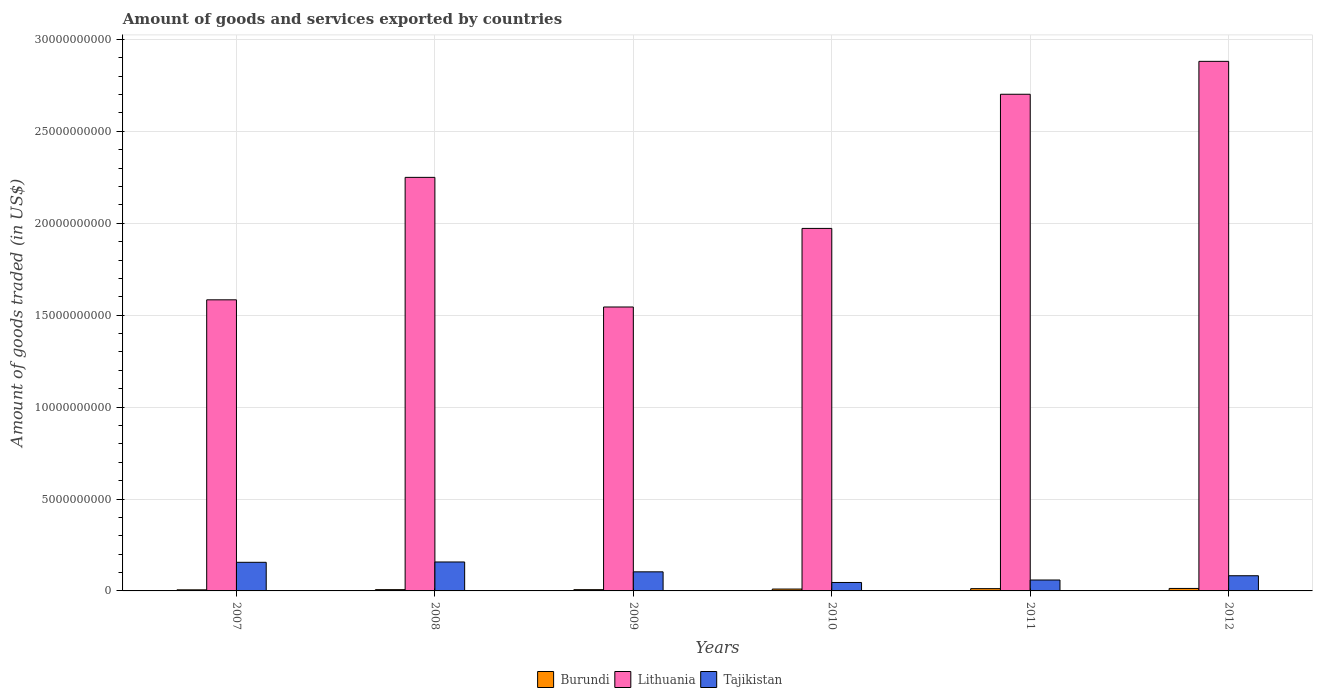How many different coloured bars are there?
Your answer should be very brief. 3. How many groups of bars are there?
Your response must be concise. 6. Are the number of bars per tick equal to the number of legend labels?
Offer a terse response. Yes. Are the number of bars on each tick of the X-axis equal?
Provide a short and direct response. Yes. How many bars are there on the 3rd tick from the left?
Your answer should be very brief. 3. How many bars are there on the 3rd tick from the right?
Provide a succinct answer. 3. In how many cases, is the number of bars for a given year not equal to the number of legend labels?
Your answer should be very brief. 0. What is the total amount of goods and services exported in Lithuania in 2007?
Ensure brevity in your answer.  1.58e+1. Across all years, what is the maximum total amount of goods and services exported in Burundi?
Keep it short and to the point. 1.35e+08. Across all years, what is the minimum total amount of goods and services exported in Tajikistan?
Give a very brief answer. 4.59e+08. In which year was the total amount of goods and services exported in Lithuania maximum?
Provide a succinct answer. 2012. What is the total total amount of goods and services exported in Lithuania in the graph?
Offer a terse response. 1.29e+11. What is the difference between the total amount of goods and services exported in Tajikistan in 2007 and that in 2008?
Keep it short and to the point. -1.80e+07. What is the difference between the total amount of goods and services exported in Burundi in 2009 and the total amount of goods and services exported in Lithuania in 2012?
Provide a short and direct response. -2.87e+1. What is the average total amount of goods and services exported in Burundi per year?
Provide a succinct answer. 9.28e+07. In the year 2010, what is the difference between the total amount of goods and services exported in Lithuania and total amount of goods and services exported in Burundi?
Offer a very short reply. 1.96e+1. What is the ratio of the total amount of goods and services exported in Tajikistan in 2007 to that in 2010?
Offer a terse response. 3.39. Is the total amount of goods and services exported in Tajikistan in 2007 less than that in 2011?
Provide a succinct answer. No. Is the difference between the total amount of goods and services exported in Lithuania in 2007 and 2012 greater than the difference between the total amount of goods and services exported in Burundi in 2007 and 2012?
Provide a short and direct response. No. What is the difference between the highest and the second highest total amount of goods and services exported in Tajikistan?
Provide a short and direct response. 1.80e+07. What is the difference between the highest and the lowest total amount of goods and services exported in Burundi?
Keep it short and to the point. 7.59e+07. In how many years, is the total amount of goods and services exported in Lithuania greater than the average total amount of goods and services exported in Lithuania taken over all years?
Your answer should be very brief. 3. What does the 3rd bar from the left in 2010 represents?
Your answer should be compact. Tajikistan. What does the 3rd bar from the right in 2009 represents?
Make the answer very short. Burundi. Are the values on the major ticks of Y-axis written in scientific E-notation?
Ensure brevity in your answer.  No. Does the graph contain any zero values?
Make the answer very short. No. How are the legend labels stacked?
Your answer should be compact. Horizontal. What is the title of the graph?
Your answer should be compact. Amount of goods and services exported by countries. Does "Suriname" appear as one of the legend labels in the graph?
Make the answer very short. No. What is the label or title of the Y-axis?
Offer a terse response. Amount of goods traded (in US$). What is the Amount of goods traded (in US$) in Burundi in 2007?
Keep it short and to the point. 5.88e+07. What is the Amount of goods traded (in US$) of Lithuania in 2007?
Offer a very short reply. 1.58e+1. What is the Amount of goods traded (in US$) in Tajikistan in 2007?
Give a very brief answer. 1.56e+09. What is the Amount of goods traded (in US$) in Burundi in 2008?
Offer a terse response. 6.96e+07. What is the Amount of goods traded (in US$) in Lithuania in 2008?
Ensure brevity in your answer.  2.25e+1. What is the Amount of goods traded (in US$) in Tajikistan in 2008?
Ensure brevity in your answer.  1.57e+09. What is the Amount of goods traded (in US$) in Burundi in 2009?
Offer a very short reply. 6.84e+07. What is the Amount of goods traded (in US$) in Lithuania in 2009?
Ensure brevity in your answer.  1.54e+1. What is the Amount of goods traded (in US$) of Tajikistan in 2009?
Keep it short and to the point. 1.04e+09. What is the Amount of goods traded (in US$) of Burundi in 2010?
Provide a succinct answer. 1.01e+08. What is the Amount of goods traded (in US$) in Lithuania in 2010?
Keep it short and to the point. 1.97e+1. What is the Amount of goods traded (in US$) of Tajikistan in 2010?
Offer a very short reply. 4.59e+08. What is the Amount of goods traded (in US$) of Burundi in 2011?
Your response must be concise. 1.24e+08. What is the Amount of goods traded (in US$) in Lithuania in 2011?
Your answer should be compact. 2.70e+1. What is the Amount of goods traded (in US$) of Tajikistan in 2011?
Make the answer very short. 5.93e+08. What is the Amount of goods traded (in US$) in Burundi in 2012?
Ensure brevity in your answer.  1.35e+08. What is the Amount of goods traded (in US$) of Lithuania in 2012?
Make the answer very short. 2.88e+1. What is the Amount of goods traded (in US$) of Tajikistan in 2012?
Keep it short and to the point. 8.26e+08. Across all years, what is the maximum Amount of goods traded (in US$) in Burundi?
Make the answer very short. 1.35e+08. Across all years, what is the maximum Amount of goods traded (in US$) in Lithuania?
Make the answer very short. 2.88e+1. Across all years, what is the maximum Amount of goods traded (in US$) of Tajikistan?
Your answer should be very brief. 1.57e+09. Across all years, what is the minimum Amount of goods traded (in US$) in Burundi?
Give a very brief answer. 5.88e+07. Across all years, what is the minimum Amount of goods traded (in US$) of Lithuania?
Provide a short and direct response. 1.54e+1. Across all years, what is the minimum Amount of goods traded (in US$) of Tajikistan?
Keep it short and to the point. 4.59e+08. What is the total Amount of goods traded (in US$) of Burundi in the graph?
Give a very brief answer. 5.57e+08. What is the total Amount of goods traded (in US$) in Lithuania in the graph?
Your response must be concise. 1.29e+11. What is the total Amount of goods traded (in US$) of Tajikistan in the graph?
Your answer should be very brief. 6.05e+09. What is the difference between the Amount of goods traded (in US$) in Burundi in 2007 and that in 2008?
Your answer should be compact. -1.08e+07. What is the difference between the Amount of goods traded (in US$) in Lithuania in 2007 and that in 2008?
Offer a terse response. -6.66e+09. What is the difference between the Amount of goods traded (in US$) of Tajikistan in 2007 and that in 2008?
Provide a succinct answer. -1.80e+07. What is the difference between the Amount of goods traded (in US$) in Burundi in 2007 and that in 2009?
Your answer should be very brief. -9.58e+06. What is the difference between the Amount of goods traded (in US$) in Lithuania in 2007 and that in 2009?
Offer a terse response. 3.91e+08. What is the difference between the Amount of goods traded (in US$) in Tajikistan in 2007 and that in 2009?
Give a very brief answer. 5.18e+08. What is the difference between the Amount of goods traded (in US$) of Burundi in 2007 and that in 2010?
Make the answer very short. -4.24e+07. What is the difference between the Amount of goods traded (in US$) of Lithuania in 2007 and that in 2010?
Keep it short and to the point. -3.88e+09. What is the difference between the Amount of goods traded (in US$) in Tajikistan in 2007 and that in 2010?
Ensure brevity in your answer.  1.10e+09. What is the difference between the Amount of goods traded (in US$) of Burundi in 2007 and that in 2011?
Your response must be concise. -6.51e+07. What is the difference between the Amount of goods traded (in US$) in Lithuania in 2007 and that in 2011?
Keep it short and to the point. -1.12e+1. What is the difference between the Amount of goods traded (in US$) in Tajikistan in 2007 and that in 2011?
Offer a terse response. 9.64e+08. What is the difference between the Amount of goods traded (in US$) in Burundi in 2007 and that in 2012?
Offer a terse response. -7.59e+07. What is the difference between the Amount of goods traded (in US$) of Lithuania in 2007 and that in 2012?
Make the answer very short. -1.30e+1. What is the difference between the Amount of goods traded (in US$) in Tajikistan in 2007 and that in 2012?
Offer a terse response. 7.31e+08. What is the difference between the Amount of goods traded (in US$) in Burundi in 2008 and that in 2009?
Keep it short and to the point. 1.23e+06. What is the difference between the Amount of goods traded (in US$) in Lithuania in 2008 and that in 2009?
Make the answer very short. 7.05e+09. What is the difference between the Amount of goods traded (in US$) in Tajikistan in 2008 and that in 2009?
Give a very brief answer. 5.36e+08. What is the difference between the Amount of goods traded (in US$) in Burundi in 2008 and that in 2010?
Provide a succinct answer. -3.16e+07. What is the difference between the Amount of goods traded (in US$) of Lithuania in 2008 and that in 2010?
Keep it short and to the point. 2.78e+09. What is the difference between the Amount of goods traded (in US$) of Tajikistan in 2008 and that in 2010?
Ensure brevity in your answer.  1.12e+09. What is the difference between the Amount of goods traded (in US$) of Burundi in 2008 and that in 2011?
Provide a succinct answer. -5.43e+07. What is the difference between the Amount of goods traded (in US$) of Lithuania in 2008 and that in 2011?
Keep it short and to the point. -4.52e+09. What is the difference between the Amount of goods traded (in US$) of Tajikistan in 2008 and that in 2011?
Offer a terse response. 9.82e+08. What is the difference between the Amount of goods traded (in US$) in Burundi in 2008 and that in 2012?
Give a very brief answer. -6.51e+07. What is the difference between the Amount of goods traded (in US$) of Lithuania in 2008 and that in 2012?
Your answer should be very brief. -6.31e+09. What is the difference between the Amount of goods traded (in US$) of Tajikistan in 2008 and that in 2012?
Your answer should be compact. 7.49e+08. What is the difference between the Amount of goods traded (in US$) in Burundi in 2009 and that in 2010?
Provide a short and direct response. -3.28e+07. What is the difference between the Amount of goods traded (in US$) in Lithuania in 2009 and that in 2010?
Give a very brief answer. -4.27e+09. What is the difference between the Amount of goods traded (in US$) in Tajikistan in 2009 and that in 2010?
Your answer should be very brief. 5.79e+08. What is the difference between the Amount of goods traded (in US$) in Burundi in 2009 and that in 2011?
Make the answer very short. -5.56e+07. What is the difference between the Amount of goods traded (in US$) of Lithuania in 2009 and that in 2011?
Offer a very short reply. -1.16e+1. What is the difference between the Amount of goods traded (in US$) in Tajikistan in 2009 and that in 2011?
Your response must be concise. 4.45e+08. What is the difference between the Amount of goods traded (in US$) of Burundi in 2009 and that in 2012?
Provide a short and direct response. -6.63e+07. What is the difference between the Amount of goods traded (in US$) of Lithuania in 2009 and that in 2012?
Provide a succinct answer. -1.34e+1. What is the difference between the Amount of goods traded (in US$) in Tajikistan in 2009 and that in 2012?
Your response must be concise. 2.13e+08. What is the difference between the Amount of goods traded (in US$) in Burundi in 2010 and that in 2011?
Offer a terse response. -2.27e+07. What is the difference between the Amount of goods traded (in US$) of Lithuania in 2010 and that in 2011?
Ensure brevity in your answer.  -7.30e+09. What is the difference between the Amount of goods traded (in US$) in Tajikistan in 2010 and that in 2011?
Ensure brevity in your answer.  -1.34e+08. What is the difference between the Amount of goods traded (in US$) in Burundi in 2010 and that in 2012?
Make the answer very short. -3.35e+07. What is the difference between the Amount of goods traded (in US$) in Lithuania in 2010 and that in 2012?
Keep it short and to the point. -9.09e+09. What is the difference between the Amount of goods traded (in US$) in Tajikistan in 2010 and that in 2012?
Your response must be concise. -3.67e+08. What is the difference between the Amount of goods traded (in US$) in Burundi in 2011 and that in 2012?
Your answer should be compact. -1.07e+07. What is the difference between the Amount of goods traded (in US$) in Lithuania in 2011 and that in 2012?
Make the answer very short. -1.79e+09. What is the difference between the Amount of goods traded (in US$) of Tajikistan in 2011 and that in 2012?
Make the answer very short. -2.33e+08. What is the difference between the Amount of goods traded (in US$) in Burundi in 2007 and the Amount of goods traded (in US$) in Lithuania in 2008?
Make the answer very short. -2.24e+1. What is the difference between the Amount of goods traded (in US$) of Burundi in 2007 and the Amount of goods traded (in US$) of Tajikistan in 2008?
Provide a short and direct response. -1.52e+09. What is the difference between the Amount of goods traded (in US$) in Lithuania in 2007 and the Amount of goods traded (in US$) in Tajikistan in 2008?
Offer a very short reply. 1.43e+1. What is the difference between the Amount of goods traded (in US$) in Burundi in 2007 and the Amount of goods traded (in US$) in Lithuania in 2009?
Your response must be concise. -1.54e+1. What is the difference between the Amount of goods traded (in US$) of Burundi in 2007 and the Amount of goods traded (in US$) of Tajikistan in 2009?
Give a very brief answer. -9.80e+08. What is the difference between the Amount of goods traded (in US$) of Lithuania in 2007 and the Amount of goods traded (in US$) of Tajikistan in 2009?
Keep it short and to the point. 1.48e+1. What is the difference between the Amount of goods traded (in US$) of Burundi in 2007 and the Amount of goods traded (in US$) of Lithuania in 2010?
Provide a short and direct response. -1.97e+1. What is the difference between the Amount of goods traded (in US$) of Burundi in 2007 and the Amount of goods traded (in US$) of Tajikistan in 2010?
Make the answer very short. -4.00e+08. What is the difference between the Amount of goods traded (in US$) of Lithuania in 2007 and the Amount of goods traded (in US$) of Tajikistan in 2010?
Offer a terse response. 1.54e+1. What is the difference between the Amount of goods traded (in US$) in Burundi in 2007 and the Amount of goods traded (in US$) in Lithuania in 2011?
Your answer should be very brief. -2.70e+1. What is the difference between the Amount of goods traded (in US$) of Burundi in 2007 and the Amount of goods traded (in US$) of Tajikistan in 2011?
Offer a terse response. -5.35e+08. What is the difference between the Amount of goods traded (in US$) in Lithuania in 2007 and the Amount of goods traded (in US$) in Tajikistan in 2011?
Make the answer very short. 1.52e+1. What is the difference between the Amount of goods traded (in US$) of Burundi in 2007 and the Amount of goods traded (in US$) of Lithuania in 2012?
Give a very brief answer. -2.87e+1. What is the difference between the Amount of goods traded (in US$) in Burundi in 2007 and the Amount of goods traded (in US$) in Tajikistan in 2012?
Provide a succinct answer. -7.67e+08. What is the difference between the Amount of goods traded (in US$) in Lithuania in 2007 and the Amount of goods traded (in US$) in Tajikistan in 2012?
Your answer should be compact. 1.50e+1. What is the difference between the Amount of goods traded (in US$) of Burundi in 2008 and the Amount of goods traded (in US$) of Lithuania in 2009?
Your answer should be very brief. -1.54e+1. What is the difference between the Amount of goods traded (in US$) of Burundi in 2008 and the Amount of goods traded (in US$) of Tajikistan in 2009?
Offer a very short reply. -9.69e+08. What is the difference between the Amount of goods traded (in US$) in Lithuania in 2008 and the Amount of goods traded (in US$) in Tajikistan in 2009?
Keep it short and to the point. 2.15e+1. What is the difference between the Amount of goods traded (in US$) of Burundi in 2008 and the Amount of goods traded (in US$) of Lithuania in 2010?
Offer a very short reply. -1.97e+1. What is the difference between the Amount of goods traded (in US$) of Burundi in 2008 and the Amount of goods traded (in US$) of Tajikistan in 2010?
Provide a succinct answer. -3.89e+08. What is the difference between the Amount of goods traded (in US$) of Lithuania in 2008 and the Amount of goods traded (in US$) of Tajikistan in 2010?
Offer a terse response. 2.20e+1. What is the difference between the Amount of goods traded (in US$) in Burundi in 2008 and the Amount of goods traded (in US$) in Lithuania in 2011?
Give a very brief answer. -2.69e+1. What is the difference between the Amount of goods traded (in US$) in Burundi in 2008 and the Amount of goods traded (in US$) in Tajikistan in 2011?
Ensure brevity in your answer.  -5.24e+08. What is the difference between the Amount of goods traded (in US$) in Lithuania in 2008 and the Amount of goods traded (in US$) in Tajikistan in 2011?
Your response must be concise. 2.19e+1. What is the difference between the Amount of goods traded (in US$) in Burundi in 2008 and the Amount of goods traded (in US$) in Lithuania in 2012?
Keep it short and to the point. -2.87e+1. What is the difference between the Amount of goods traded (in US$) of Burundi in 2008 and the Amount of goods traded (in US$) of Tajikistan in 2012?
Offer a terse response. -7.56e+08. What is the difference between the Amount of goods traded (in US$) of Lithuania in 2008 and the Amount of goods traded (in US$) of Tajikistan in 2012?
Give a very brief answer. 2.17e+1. What is the difference between the Amount of goods traded (in US$) in Burundi in 2009 and the Amount of goods traded (in US$) in Lithuania in 2010?
Give a very brief answer. -1.97e+1. What is the difference between the Amount of goods traded (in US$) of Burundi in 2009 and the Amount of goods traded (in US$) of Tajikistan in 2010?
Offer a terse response. -3.91e+08. What is the difference between the Amount of goods traded (in US$) in Lithuania in 2009 and the Amount of goods traded (in US$) in Tajikistan in 2010?
Ensure brevity in your answer.  1.50e+1. What is the difference between the Amount of goods traded (in US$) of Burundi in 2009 and the Amount of goods traded (in US$) of Lithuania in 2011?
Keep it short and to the point. -2.69e+1. What is the difference between the Amount of goods traded (in US$) in Burundi in 2009 and the Amount of goods traded (in US$) in Tajikistan in 2011?
Make the answer very short. -5.25e+08. What is the difference between the Amount of goods traded (in US$) of Lithuania in 2009 and the Amount of goods traded (in US$) of Tajikistan in 2011?
Your response must be concise. 1.49e+1. What is the difference between the Amount of goods traded (in US$) in Burundi in 2009 and the Amount of goods traded (in US$) in Lithuania in 2012?
Provide a succinct answer. -2.87e+1. What is the difference between the Amount of goods traded (in US$) of Burundi in 2009 and the Amount of goods traded (in US$) of Tajikistan in 2012?
Your answer should be compact. -7.58e+08. What is the difference between the Amount of goods traded (in US$) in Lithuania in 2009 and the Amount of goods traded (in US$) in Tajikistan in 2012?
Offer a terse response. 1.46e+1. What is the difference between the Amount of goods traded (in US$) of Burundi in 2010 and the Amount of goods traded (in US$) of Lithuania in 2011?
Provide a succinct answer. -2.69e+1. What is the difference between the Amount of goods traded (in US$) in Burundi in 2010 and the Amount of goods traded (in US$) in Tajikistan in 2011?
Offer a terse response. -4.92e+08. What is the difference between the Amount of goods traded (in US$) in Lithuania in 2010 and the Amount of goods traded (in US$) in Tajikistan in 2011?
Provide a short and direct response. 1.91e+1. What is the difference between the Amount of goods traded (in US$) of Burundi in 2010 and the Amount of goods traded (in US$) of Lithuania in 2012?
Provide a succinct answer. -2.87e+1. What is the difference between the Amount of goods traded (in US$) in Burundi in 2010 and the Amount of goods traded (in US$) in Tajikistan in 2012?
Give a very brief answer. -7.25e+08. What is the difference between the Amount of goods traded (in US$) of Lithuania in 2010 and the Amount of goods traded (in US$) of Tajikistan in 2012?
Provide a short and direct response. 1.89e+1. What is the difference between the Amount of goods traded (in US$) of Burundi in 2011 and the Amount of goods traded (in US$) of Lithuania in 2012?
Provide a short and direct response. -2.87e+1. What is the difference between the Amount of goods traded (in US$) in Burundi in 2011 and the Amount of goods traded (in US$) in Tajikistan in 2012?
Offer a terse response. -7.02e+08. What is the difference between the Amount of goods traded (in US$) in Lithuania in 2011 and the Amount of goods traded (in US$) in Tajikistan in 2012?
Provide a succinct answer. 2.62e+1. What is the average Amount of goods traded (in US$) of Burundi per year?
Your response must be concise. 9.28e+07. What is the average Amount of goods traded (in US$) in Lithuania per year?
Offer a very short reply. 2.16e+1. What is the average Amount of goods traded (in US$) of Tajikistan per year?
Ensure brevity in your answer.  1.01e+09. In the year 2007, what is the difference between the Amount of goods traded (in US$) in Burundi and Amount of goods traded (in US$) in Lithuania?
Your response must be concise. -1.58e+1. In the year 2007, what is the difference between the Amount of goods traded (in US$) of Burundi and Amount of goods traded (in US$) of Tajikistan?
Provide a succinct answer. -1.50e+09. In the year 2007, what is the difference between the Amount of goods traded (in US$) of Lithuania and Amount of goods traded (in US$) of Tajikistan?
Provide a succinct answer. 1.43e+1. In the year 2008, what is the difference between the Amount of goods traded (in US$) in Burundi and Amount of goods traded (in US$) in Lithuania?
Your answer should be compact. -2.24e+1. In the year 2008, what is the difference between the Amount of goods traded (in US$) of Burundi and Amount of goods traded (in US$) of Tajikistan?
Your response must be concise. -1.51e+09. In the year 2008, what is the difference between the Amount of goods traded (in US$) of Lithuania and Amount of goods traded (in US$) of Tajikistan?
Ensure brevity in your answer.  2.09e+1. In the year 2009, what is the difference between the Amount of goods traded (in US$) of Burundi and Amount of goods traded (in US$) of Lithuania?
Offer a very short reply. -1.54e+1. In the year 2009, what is the difference between the Amount of goods traded (in US$) of Burundi and Amount of goods traded (in US$) of Tajikistan?
Provide a succinct answer. -9.70e+08. In the year 2009, what is the difference between the Amount of goods traded (in US$) of Lithuania and Amount of goods traded (in US$) of Tajikistan?
Make the answer very short. 1.44e+1. In the year 2010, what is the difference between the Amount of goods traded (in US$) of Burundi and Amount of goods traded (in US$) of Lithuania?
Offer a terse response. -1.96e+1. In the year 2010, what is the difference between the Amount of goods traded (in US$) of Burundi and Amount of goods traded (in US$) of Tajikistan?
Offer a terse response. -3.58e+08. In the year 2010, what is the difference between the Amount of goods traded (in US$) of Lithuania and Amount of goods traded (in US$) of Tajikistan?
Offer a terse response. 1.93e+1. In the year 2011, what is the difference between the Amount of goods traded (in US$) in Burundi and Amount of goods traded (in US$) in Lithuania?
Provide a succinct answer. -2.69e+1. In the year 2011, what is the difference between the Amount of goods traded (in US$) in Burundi and Amount of goods traded (in US$) in Tajikistan?
Keep it short and to the point. -4.69e+08. In the year 2011, what is the difference between the Amount of goods traded (in US$) in Lithuania and Amount of goods traded (in US$) in Tajikistan?
Offer a terse response. 2.64e+1. In the year 2012, what is the difference between the Amount of goods traded (in US$) in Burundi and Amount of goods traded (in US$) in Lithuania?
Offer a very short reply. -2.87e+1. In the year 2012, what is the difference between the Amount of goods traded (in US$) of Burundi and Amount of goods traded (in US$) of Tajikistan?
Your answer should be compact. -6.91e+08. In the year 2012, what is the difference between the Amount of goods traded (in US$) of Lithuania and Amount of goods traded (in US$) of Tajikistan?
Offer a very short reply. 2.80e+1. What is the ratio of the Amount of goods traded (in US$) of Burundi in 2007 to that in 2008?
Your answer should be compact. 0.84. What is the ratio of the Amount of goods traded (in US$) of Lithuania in 2007 to that in 2008?
Provide a short and direct response. 0.7. What is the ratio of the Amount of goods traded (in US$) in Burundi in 2007 to that in 2009?
Your answer should be compact. 0.86. What is the ratio of the Amount of goods traded (in US$) of Lithuania in 2007 to that in 2009?
Keep it short and to the point. 1.03. What is the ratio of the Amount of goods traded (in US$) in Tajikistan in 2007 to that in 2009?
Give a very brief answer. 1.5. What is the ratio of the Amount of goods traded (in US$) in Burundi in 2007 to that in 2010?
Provide a succinct answer. 0.58. What is the ratio of the Amount of goods traded (in US$) of Lithuania in 2007 to that in 2010?
Provide a succinct answer. 0.8. What is the ratio of the Amount of goods traded (in US$) in Tajikistan in 2007 to that in 2010?
Offer a very short reply. 3.39. What is the ratio of the Amount of goods traded (in US$) in Burundi in 2007 to that in 2011?
Your answer should be very brief. 0.47. What is the ratio of the Amount of goods traded (in US$) in Lithuania in 2007 to that in 2011?
Ensure brevity in your answer.  0.59. What is the ratio of the Amount of goods traded (in US$) in Tajikistan in 2007 to that in 2011?
Your answer should be compact. 2.62. What is the ratio of the Amount of goods traded (in US$) in Burundi in 2007 to that in 2012?
Provide a short and direct response. 0.44. What is the ratio of the Amount of goods traded (in US$) in Lithuania in 2007 to that in 2012?
Provide a succinct answer. 0.55. What is the ratio of the Amount of goods traded (in US$) of Tajikistan in 2007 to that in 2012?
Your response must be concise. 1.89. What is the ratio of the Amount of goods traded (in US$) in Burundi in 2008 to that in 2009?
Your answer should be compact. 1.02. What is the ratio of the Amount of goods traded (in US$) in Lithuania in 2008 to that in 2009?
Provide a succinct answer. 1.46. What is the ratio of the Amount of goods traded (in US$) in Tajikistan in 2008 to that in 2009?
Offer a very short reply. 1.52. What is the ratio of the Amount of goods traded (in US$) in Burundi in 2008 to that in 2010?
Your answer should be very brief. 0.69. What is the ratio of the Amount of goods traded (in US$) in Lithuania in 2008 to that in 2010?
Make the answer very short. 1.14. What is the ratio of the Amount of goods traded (in US$) of Tajikistan in 2008 to that in 2010?
Offer a terse response. 3.43. What is the ratio of the Amount of goods traded (in US$) of Burundi in 2008 to that in 2011?
Ensure brevity in your answer.  0.56. What is the ratio of the Amount of goods traded (in US$) of Lithuania in 2008 to that in 2011?
Provide a succinct answer. 0.83. What is the ratio of the Amount of goods traded (in US$) of Tajikistan in 2008 to that in 2011?
Your answer should be compact. 2.65. What is the ratio of the Amount of goods traded (in US$) of Burundi in 2008 to that in 2012?
Offer a very short reply. 0.52. What is the ratio of the Amount of goods traded (in US$) of Lithuania in 2008 to that in 2012?
Ensure brevity in your answer.  0.78. What is the ratio of the Amount of goods traded (in US$) of Tajikistan in 2008 to that in 2012?
Give a very brief answer. 1.91. What is the ratio of the Amount of goods traded (in US$) in Burundi in 2009 to that in 2010?
Offer a terse response. 0.68. What is the ratio of the Amount of goods traded (in US$) in Lithuania in 2009 to that in 2010?
Make the answer very short. 0.78. What is the ratio of the Amount of goods traded (in US$) in Tajikistan in 2009 to that in 2010?
Your response must be concise. 2.26. What is the ratio of the Amount of goods traded (in US$) of Burundi in 2009 to that in 2011?
Your answer should be very brief. 0.55. What is the ratio of the Amount of goods traded (in US$) of Lithuania in 2009 to that in 2011?
Offer a very short reply. 0.57. What is the ratio of the Amount of goods traded (in US$) of Tajikistan in 2009 to that in 2011?
Your answer should be compact. 1.75. What is the ratio of the Amount of goods traded (in US$) of Burundi in 2009 to that in 2012?
Ensure brevity in your answer.  0.51. What is the ratio of the Amount of goods traded (in US$) of Lithuania in 2009 to that in 2012?
Your answer should be very brief. 0.54. What is the ratio of the Amount of goods traded (in US$) of Tajikistan in 2009 to that in 2012?
Your response must be concise. 1.26. What is the ratio of the Amount of goods traded (in US$) in Burundi in 2010 to that in 2011?
Your answer should be compact. 0.82. What is the ratio of the Amount of goods traded (in US$) in Lithuania in 2010 to that in 2011?
Make the answer very short. 0.73. What is the ratio of the Amount of goods traded (in US$) of Tajikistan in 2010 to that in 2011?
Offer a terse response. 0.77. What is the ratio of the Amount of goods traded (in US$) of Burundi in 2010 to that in 2012?
Your answer should be compact. 0.75. What is the ratio of the Amount of goods traded (in US$) in Lithuania in 2010 to that in 2012?
Offer a very short reply. 0.68. What is the ratio of the Amount of goods traded (in US$) of Tajikistan in 2010 to that in 2012?
Offer a very short reply. 0.56. What is the ratio of the Amount of goods traded (in US$) in Burundi in 2011 to that in 2012?
Make the answer very short. 0.92. What is the ratio of the Amount of goods traded (in US$) of Lithuania in 2011 to that in 2012?
Make the answer very short. 0.94. What is the ratio of the Amount of goods traded (in US$) in Tajikistan in 2011 to that in 2012?
Keep it short and to the point. 0.72. What is the difference between the highest and the second highest Amount of goods traded (in US$) of Burundi?
Ensure brevity in your answer.  1.07e+07. What is the difference between the highest and the second highest Amount of goods traded (in US$) in Lithuania?
Keep it short and to the point. 1.79e+09. What is the difference between the highest and the second highest Amount of goods traded (in US$) of Tajikistan?
Offer a terse response. 1.80e+07. What is the difference between the highest and the lowest Amount of goods traded (in US$) in Burundi?
Keep it short and to the point. 7.59e+07. What is the difference between the highest and the lowest Amount of goods traded (in US$) of Lithuania?
Provide a succinct answer. 1.34e+1. What is the difference between the highest and the lowest Amount of goods traded (in US$) of Tajikistan?
Keep it short and to the point. 1.12e+09. 